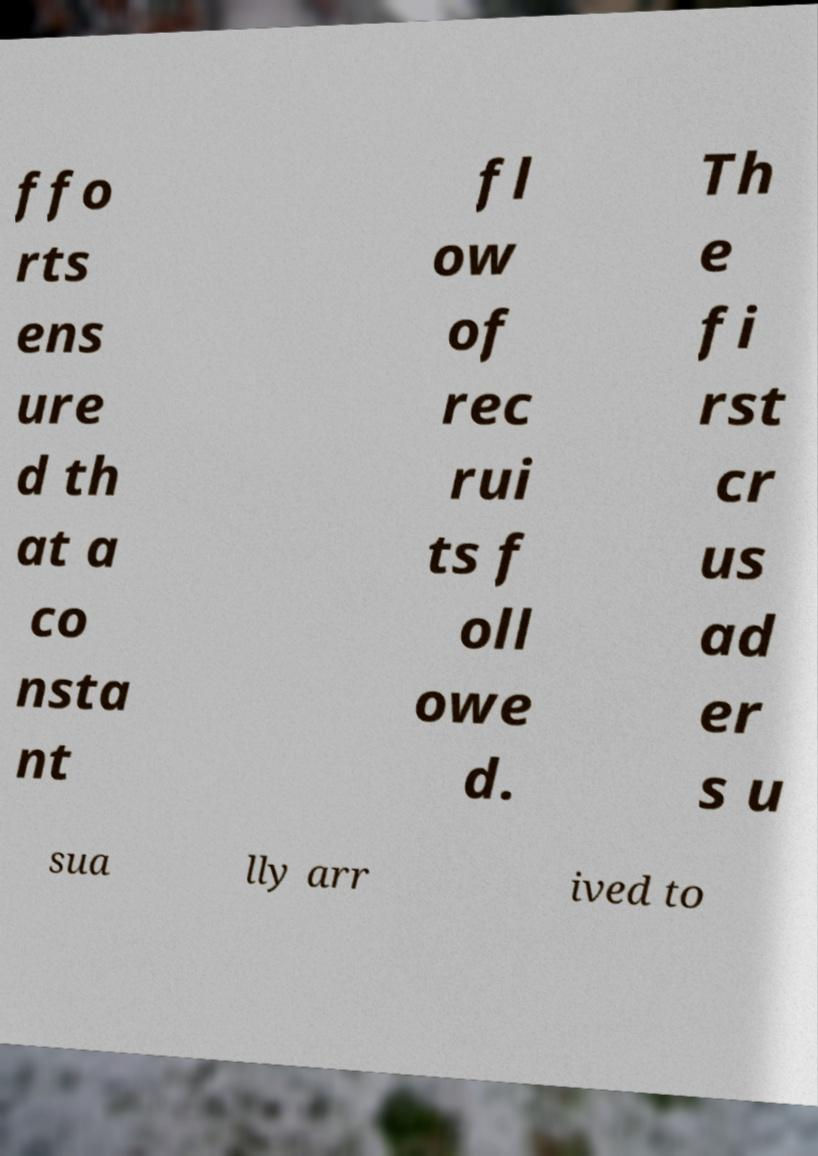There's text embedded in this image that I need extracted. Can you transcribe it verbatim? ffo rts ens ure d th at a co nsta nt fl ow of rec rui ts f oll owe d. Th e fi rst cr us ad er s u sua lly arr ived to 